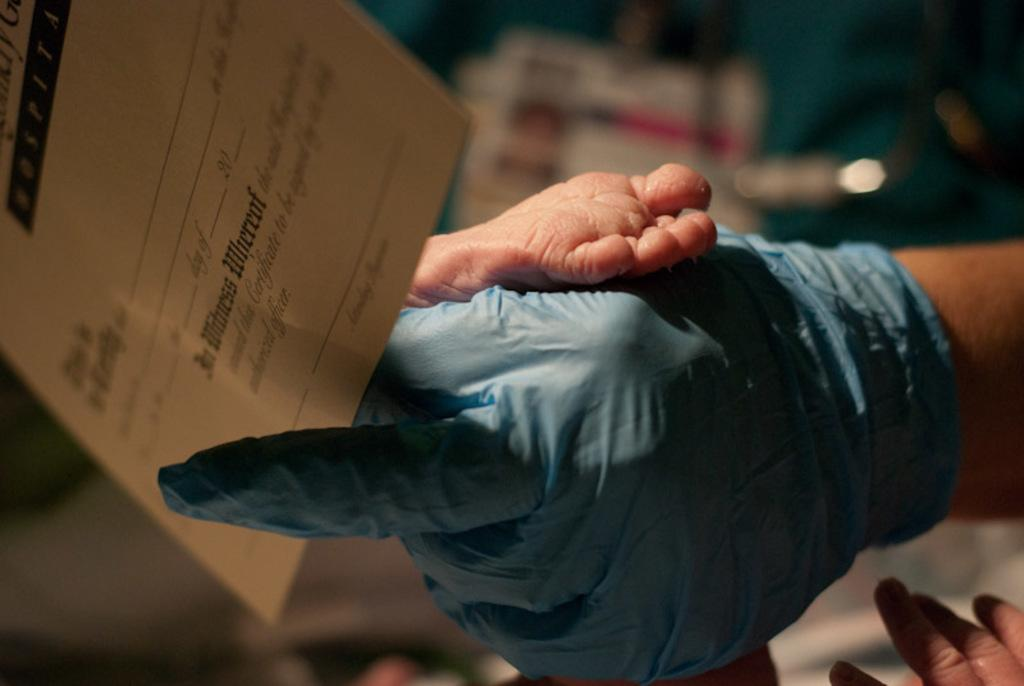What is the person holding in the image? There is a hand holding a paper in the image. What part of a baby can be seen in the image? A baby's leg is visible in the image. What can be seen in the background of the image? There is an ID card in the background of the image. What type of caption is written on the paper held by the hand in the image? There is no caption visible on the paper held by the hand in the image. What is the condition of the oranges in the image? There are no oranges present in the image. 